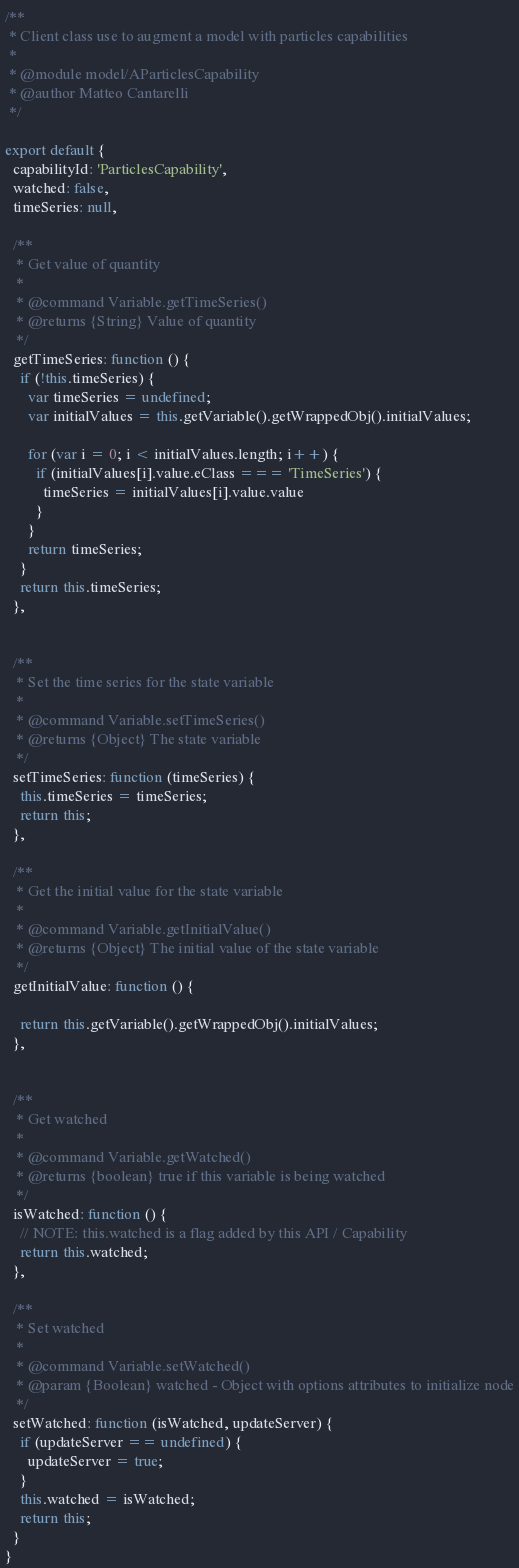Convert code to text. <code><loc_0><loc_0><loc_500><loc_500><_JavaScript_>

/**
 * Client class use to augment a model with particles capabilities
 *
 * @module model/AParticlesCapability
 * @author Matteo Cantarelli
 */

export default {
  capabilityId: 'ParticlesCapability',
  watched: false,
  timeSeries: null,

  /**
   * Get value of quantity
   *
   * @command Variable.getTimeSeries()
   * @returns {String} Value of quantity
   */
  getTimeSeries: function () {
    if (!this.timeSeries) {
      var timeSeries = undefined;
      var initialValues = this.getVariable().getWrappedObj().initialValues;

      for (var i = 0; i < initialValues.length; i++) {
        if (initialValues[i].value.eClass === 'TimeSeries') {
          timeSeries = initialValues[i].value.value
        }
      }
      return timeSeries;
    }
    return this.timeSeries;
  },


  /**
   * Set the time series for the state variable
   *
   * @command Variable.setTimeSeries()
   * @returns {Object} The state variable
   */
  setTimeSeries: function (timeSeries) {
    this.timeSeries = timeSeries;
    return this;
  },

  /**
   * Get the initial value for the state variable
   *
   * @command Variable.getInitialValue()
   * @returns {Object} The initial value of the state variable
   */
  getInitialValue: function () {

    return this.getVariable().getWrappedObj().initialValues;
  },


  /**
   * Get watched
   *
   * @command Variable.getWatched()
   * @returns {boolean} true if this variable is being watched
   */
  isWatched: function () {
    // NOTE: this.watched is a flag added by this API / Capability
    return this.watched;
  },

  /**
   * Set watched
   *
   * @command Variable.setWatched()
   * @param {Boolean} watched - Object with options attributes to initialize node
   */
  setWatched: function (isWatched, updateServer) {
    if (updateServer == undefined) {
      updateServer = true;
    }
    this.watched = isWatched;
    return this;
  }
}

</code> 